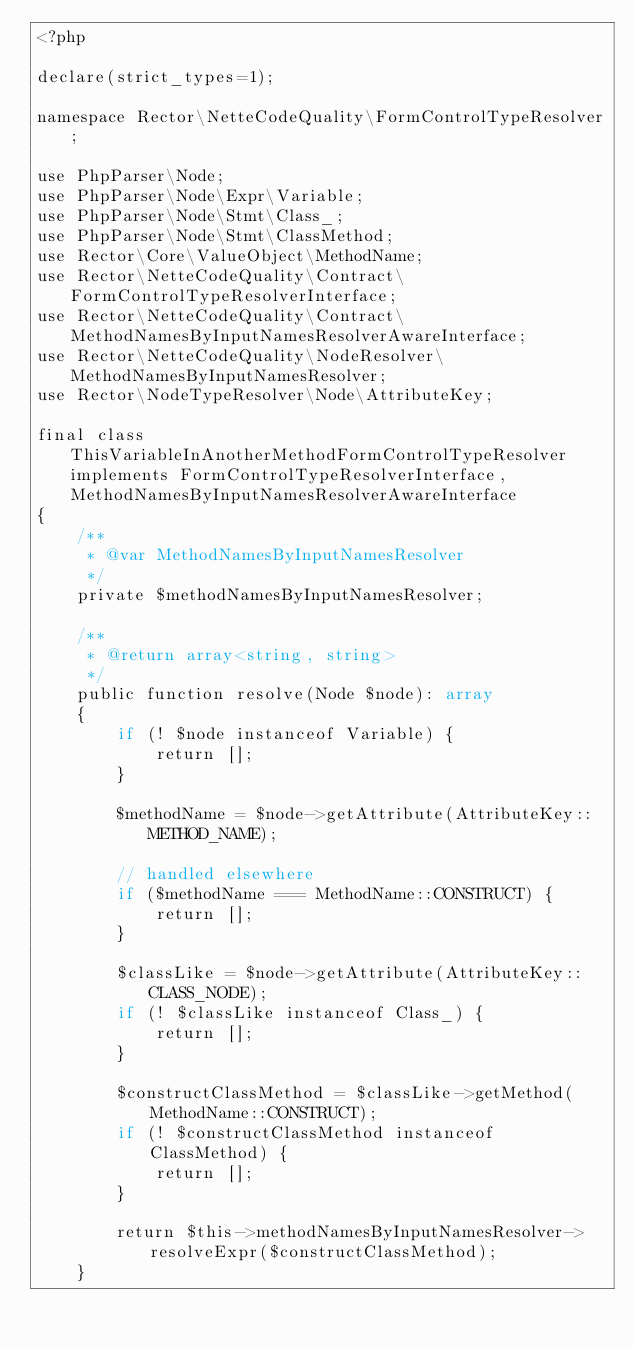Convert code to text. <code><loc_0><loc_0><loc_500><loc_500><_PHP_><?php

declare(strict_types=1);

namespace Rector\NetteCodeQuality\FormControlTypeResolver;

use PhpParser\Node;
use PhpParser\Node\Expr\Variable;
use PhpParser\Node\Stmt\Class_;
use PhpParser\Node\Stmt\ClassMethod;
use Rector\Core\ValueObject\MethodName;
use Rector\NetteCodeQuality\Contract\FormControlTypeResolverInterface;
use Rector\NetteCodeQuality\Contract\MethodNamesByInputNamesResolverAwareInterface;
use Rector\NetteCodeQuality\NodeResolver\MethodNamesByInputNamesResolver;
use Rector\NodeTypeResolver\Node\AttributeKey;

final class ThisVariableInAnotherMethodFormControlTypeResolver implements FormControlTypeResolverInterface, MethodNamesByInputNamesResolverAwareInterface
{
    /**
     * @var MethodNamesByInputNamesResolver
     */
    private $methodNamesByInputNamesResolver;

    /**
     * @return array<string, string>
     */
    public function resolve(Node $node): array
    {
        if (! $node instanceof Variable) {
            return [];
        }

        $methodName = $node->getAttribute(AttributeKey::METHOD_NAME);

        // handled elsewhere
        if ($methodName === MethodName::CONSTRUCT) {
            return [];
        }

        $classLike = $node->getAttribute(AttributeKey::CLASS_NODE);
        if (! $classLike instanceof Class_) {
            return [];
        }

        $constructClassMethod = $classLike->getMethod(MethodName::CONSTRUCT);
        if (! $constructClassMethod instanceof ClassMethod) {
            return [];
        }

        return $this->methodNamesByInputNamesResolver->resolveExpr($constructClassMethod);
    }
</code> 